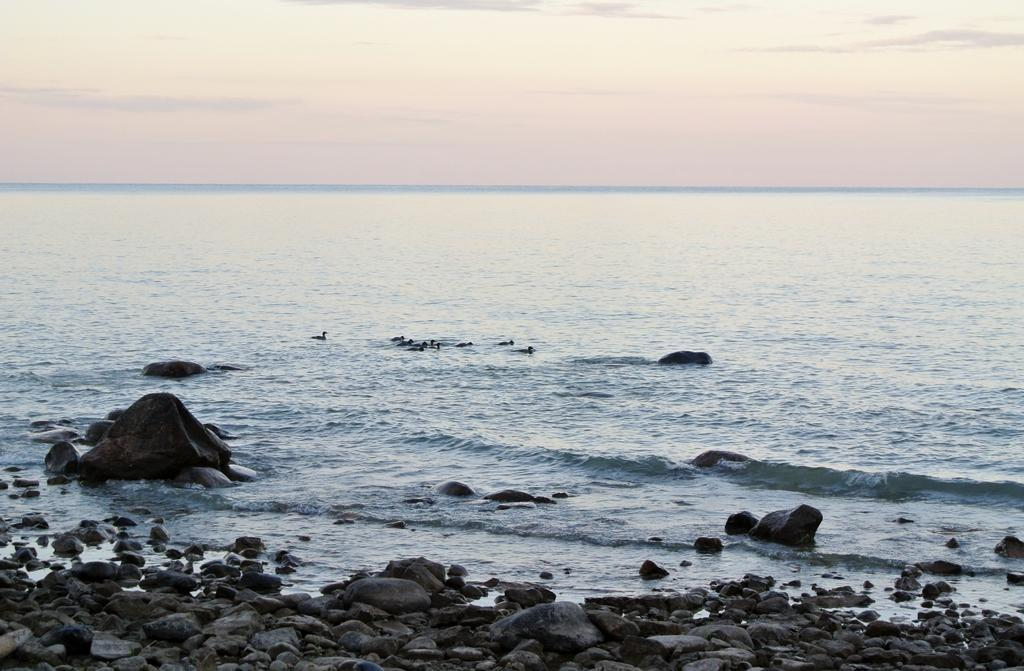What is the main subject of the image? The main subject of the image is water. What can be seen swimming in the water? There are ducks swimming in the water. What is at the bottom of the image? There are rocks at the bottom of the image. What is visible at the top of the image? The sky is visible at the top of the image. How many times can the ducks fold their wings in the image? There is no indication in the image that the ducks are folding their wings, so it cannot be determined from the picture. 